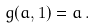Convert formula to latex. <formula><loc_0><loc_0><loc_500><loc_500>g ( a , 1 ) = a \, .</formula> 